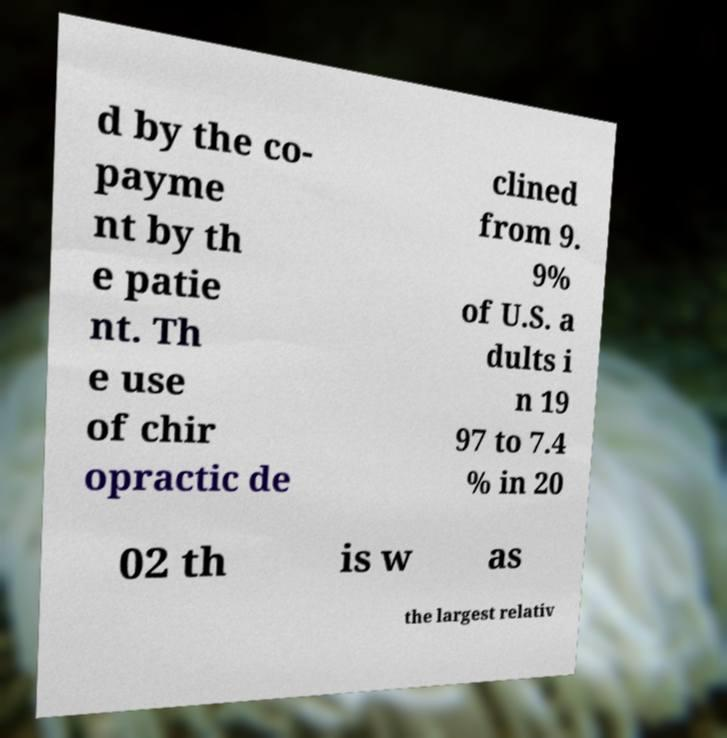Could you extract and type out the text from this image? d by the co- payme nt by th e patie nt. Th e use of chir opractic de clined from 9. 9% of U.S. a dults i n 19 97 to 7.4 % in 20 02 th is w as the largest relativ 